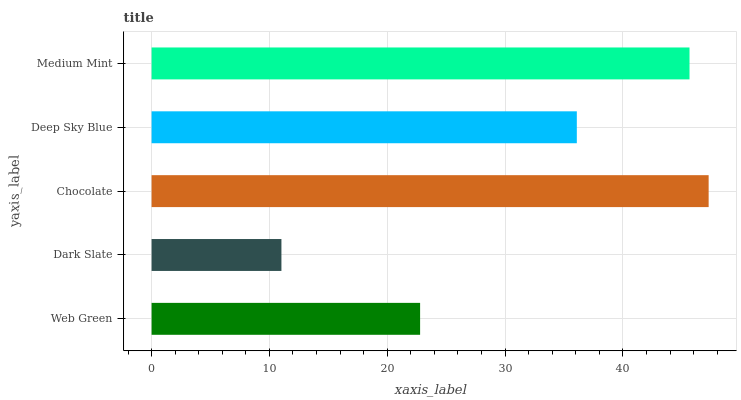Is Dark Slate the minimum?
Answer yes or no. Yes. Is Chocolate the maximum?
Answer yes or no. Yes. Is Chocolate the minimum?
Answer yes or no. No. Is Dark Slate the maximum?
Answer yes or no. No. Is Chocolate greater than Dark Slate?
Answer yes or no. Yes. Is Dark Slate less than Chocolate?
Answer yes or no. Yes. Is Dark Slate greater than Chocolate?
Answer yes or no. No. Is Chocolate less than Dark Slate?
Answer yes or no. No. Is Deep Sky Blue the high median?
Answer yes or no. Yes. Is Deep Sky Blue the low median?
Answer yes or no. Yes. Is Dark Slate the high median?
Answer yes or no. No. Is Medium Mint the low median?
Answer yes or no. No. 